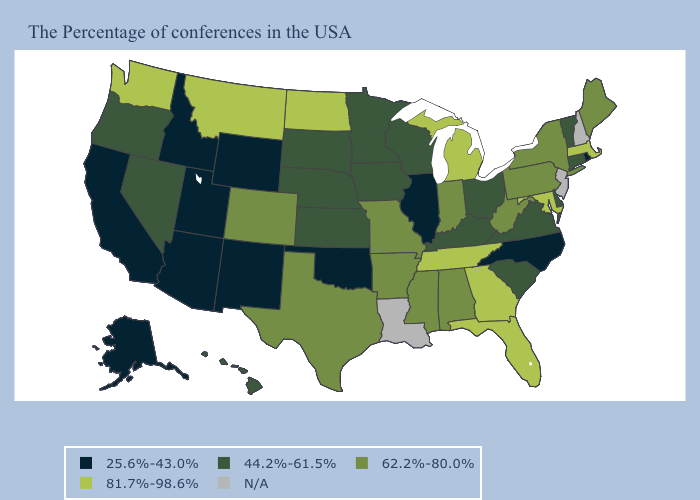What is the highest value in the USA?
Be succinct. 81.7%-98.6%. What is the highest value in states that border Utah?
Keep it brief. 62.2%-80.0%. Does Rhode Island have the lowest value in the Northeast?
Give a very brief answer. Yes. Name the states that have a value in the range N/A?
Short answer required. New Hampshire, New Jersey, Louisiana. What is the value of Idaho?
Write a very short answer. 25.6%-43.0%. Which states have the highest value in the USA?
Keep it brief. Massachusetts, Maryland, Florida, Georgia, Michigan, Tennessee, North Dakota, Montana, Washington. What is the highest value in states that border Wyoming?
Write a very short answer. 81.7%-98.6%. Name the states that have a value in the range 62.2%-80.0%?
Quick response, please. Maine, New York, Pennsylvania, West Virginia, Indiana, Alabama, Mississippi, Missouri, Arkansas, Texas, Colorado. Does North Dakota have the highest value in the MidWest?
Short answer required. Yes. Which states have the lowest value in the Northeast?
Concise answer only. Rhode Island. What is the value of Idaho?
Answer briefly. 25.6%-43.0%. What is the value of Louisiana?
Answer briefly. N/A. What is the value of Georgia?
Short answer required. 81.7%-98.6%. Does Maine have the highest value in the USA?
Write a very short answer. No. 